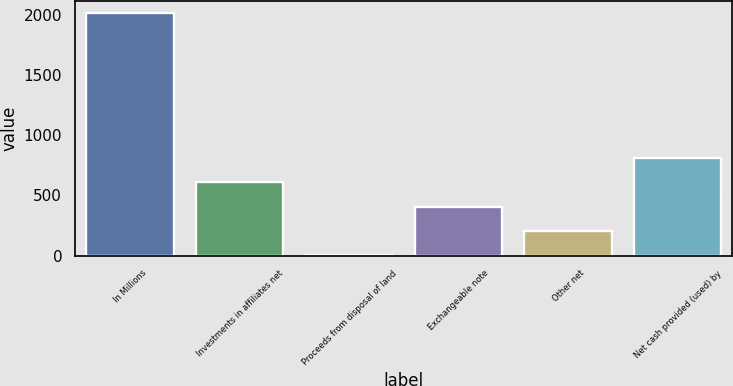Convert chart. <chart><loc_0><loc_0><loc_500><loc_500><bar_chart><fcel>In Millions<fcel>Investments in affiliates net<fcel>Proceeds from disposal of land<fcel>Exchangeable note<fcel>Other net<fcel>Net cash provided (used) by<nl><fcel>2016<fcel>607.88<fcel>4.4<fcel>406.72<fcel>205.56<fcel>809.04<nl></chart> 